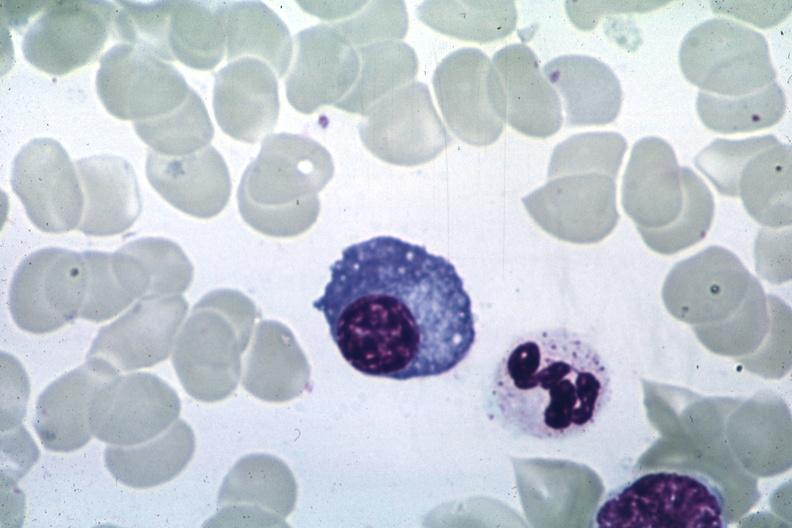what is present?
Answer the question using a single word or phrase. Plasma cell 